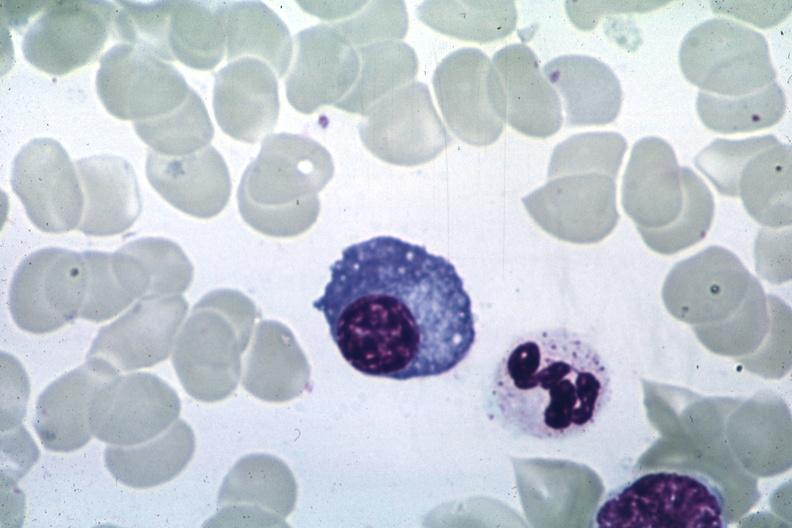what is present?
Answer the question using a single word or phrase. Plasma cell 